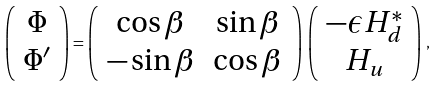Convert formula to latex. <formula><loc_0><loc_0><loc_500><loc_500>\left ( \begin{array} { c } \Phi \\ \Phi ^ { \prime } \end{array} \right ) = \left ( \begin{array} { c c } \cos \beta & \sin \beta \\ - \sin \beta & \cos \beta \end{array} \right ) \, \left ( \begin{array} { c } - \epsilon H _ { d } ^ { * } \\ H _ { u } \end{array} \right ) \, ,</formula> 